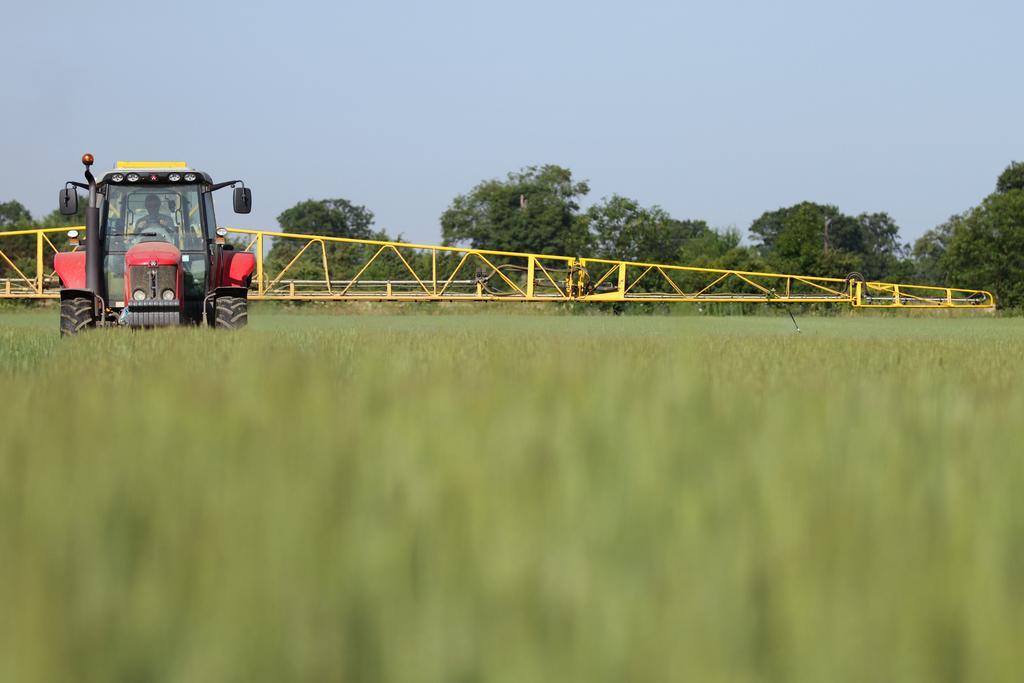How would you summarize this image in a sentence or two? In this image on the left side there is one vehicle, in that vehicle there is one person who is sitting and at the bottom there are some plants. In the background there is a bridge and trees, on the top of the image there is sky. 